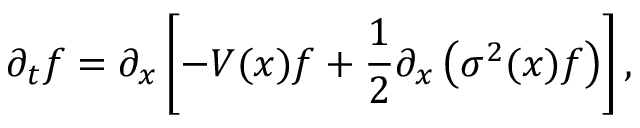Convert formula to latex. <formula><loc_0><loc_0><loc_500><loc_500>\partial _ { t } f = \partial _ { x } \left [ - V ( x ) f + \frac { 1 } { 2 } \partial _ { x } \left ( \sigma ^ { 2 } ( x ) f \right ) \right ] ,</formula> 